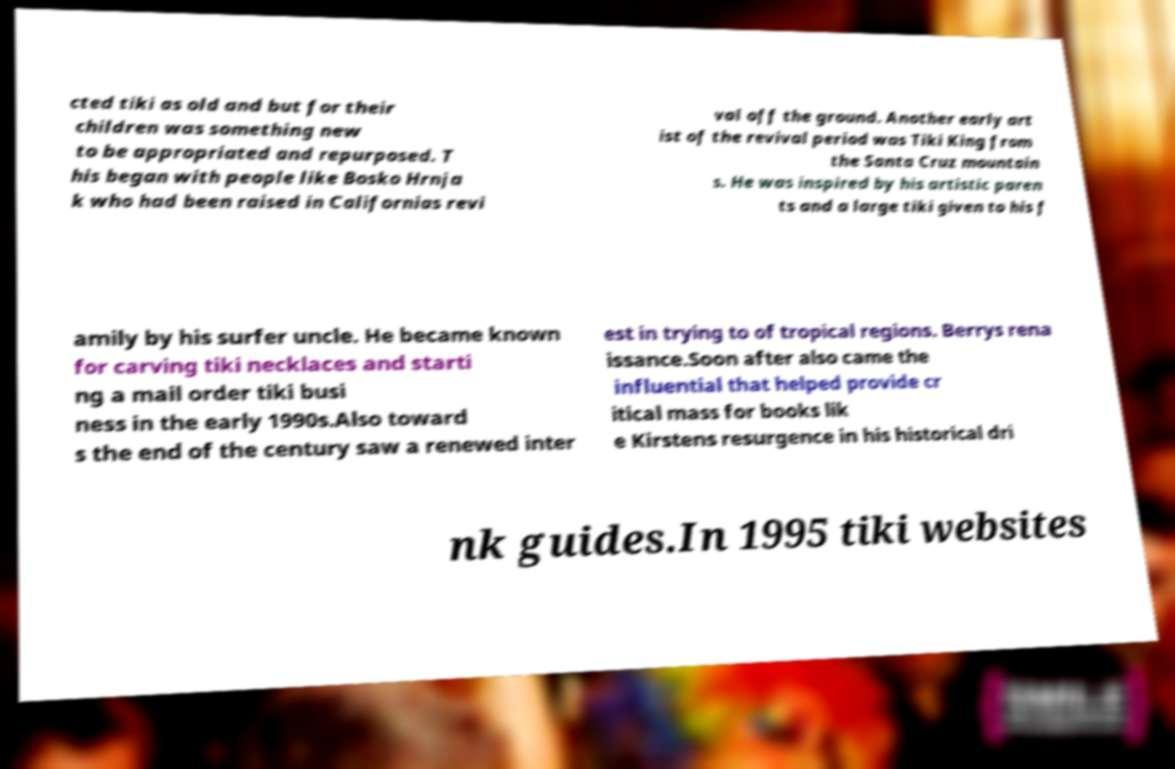Please read and relay the text visible in this image. What does it say? cted tiki as old and but for their children was something new to be appropriated and repurposed. T his began with people like Bosko Hrnja k who had been raised in Californias revi val off the ground. Another early art ist of the revival period was Tiki King from the Santa Cruz mountain s. He was inspired by his artistic paren ts and a large tiki given to his f amily by his surfer uncle. He became known for carving tiki necklaces and starti ng a mail order tiki busi ness in the early 1990s.Also toward s the end of the century saw a renewed inter est in trying to of tropical regions. Berrys rena issance.Soon after also came the influential that helped provide cr itical mass for books lik e Kirstens resurgence in his historical dri nk guides.In 1995 tiki websites 